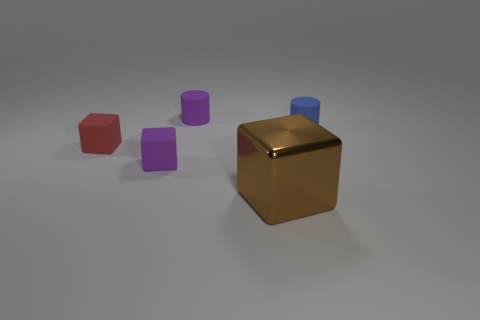Add 3 tiny purple matte blocks. How many objects exist? 8 Subtract all cubes. How many objects are left? 2 Add 3 tiny green things. How many tiny green things exist? 3 Subtract 1 blue cylinders. How many objects are left? 4 Subtract all cubes. Subtract all cylinders. How many objects are left? 0 Add 1 small red matte things. How many small red matte things are left? 2 